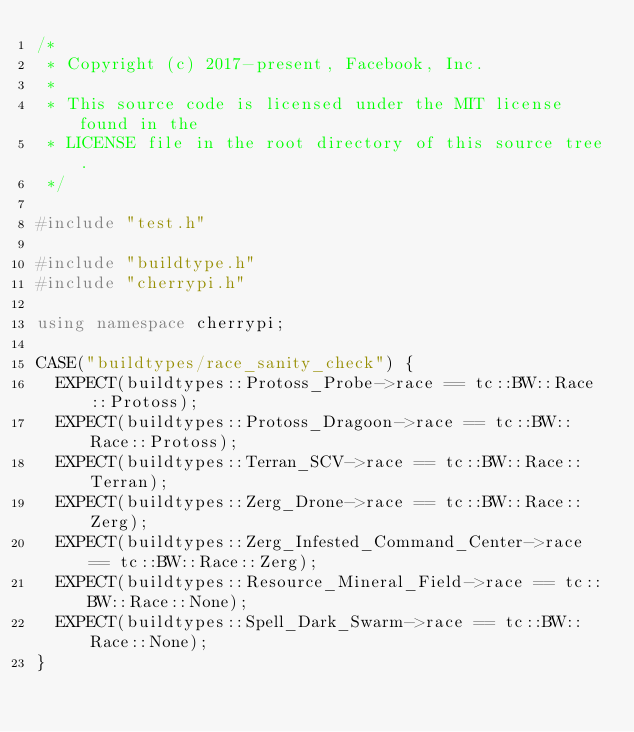<code> <loc_0><loc_0><loc_500><loc_500><_C++_>/*
 * Copyright (c) 2017-present, Facebook, Inc.
 *
 * This source code is licensed under the MIT license found in the
 * LICENSE file in the root directory of this source tree.
 */

#include "test.h"

#include "buildtype.h"
#include "cherrypi.h"

using namespace cherrypi;

CASE("buildtypes/race_sanity_check") {
  EXPECT(buildtypes::Protoss_Probe->race == tc::BW::Race::Protoss);
  EXPECT(buildtypes::Protoss_Dragoon->race == tc::BW::Race::Protoss);
  EXPECT(buildtypes::Terran_SCV->race == tc::BW::Race::Terran);
  EXPECT(buildtypes::Zerg_Drone->race == tc::BW::Race::Zerg);
  EXPECT(buildtypes::Zerg_Infested_Command_Center->race == tc::BW::Race::Zerg);
  EXPECT(buildtypes::Resource_Mineral_Field->race == tc::BW::Race::None);
  EXPECT(buildtypes::Spell_Dark_Swarm->race == tc::BW::Race::None);
}
</code> 